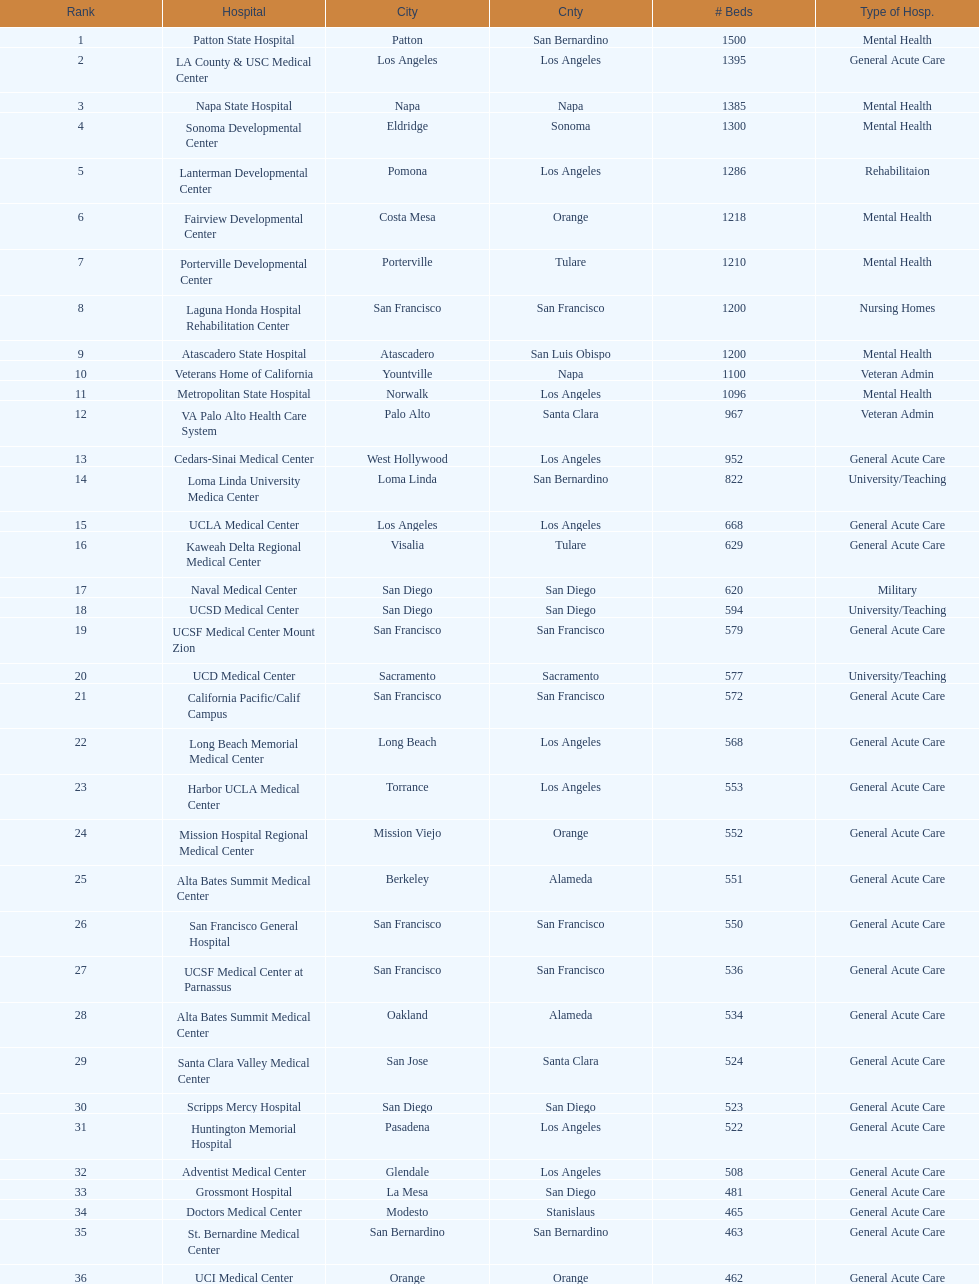How much larger (in number of beds) was the largest hospital in california than the 50th largest? 1071. 